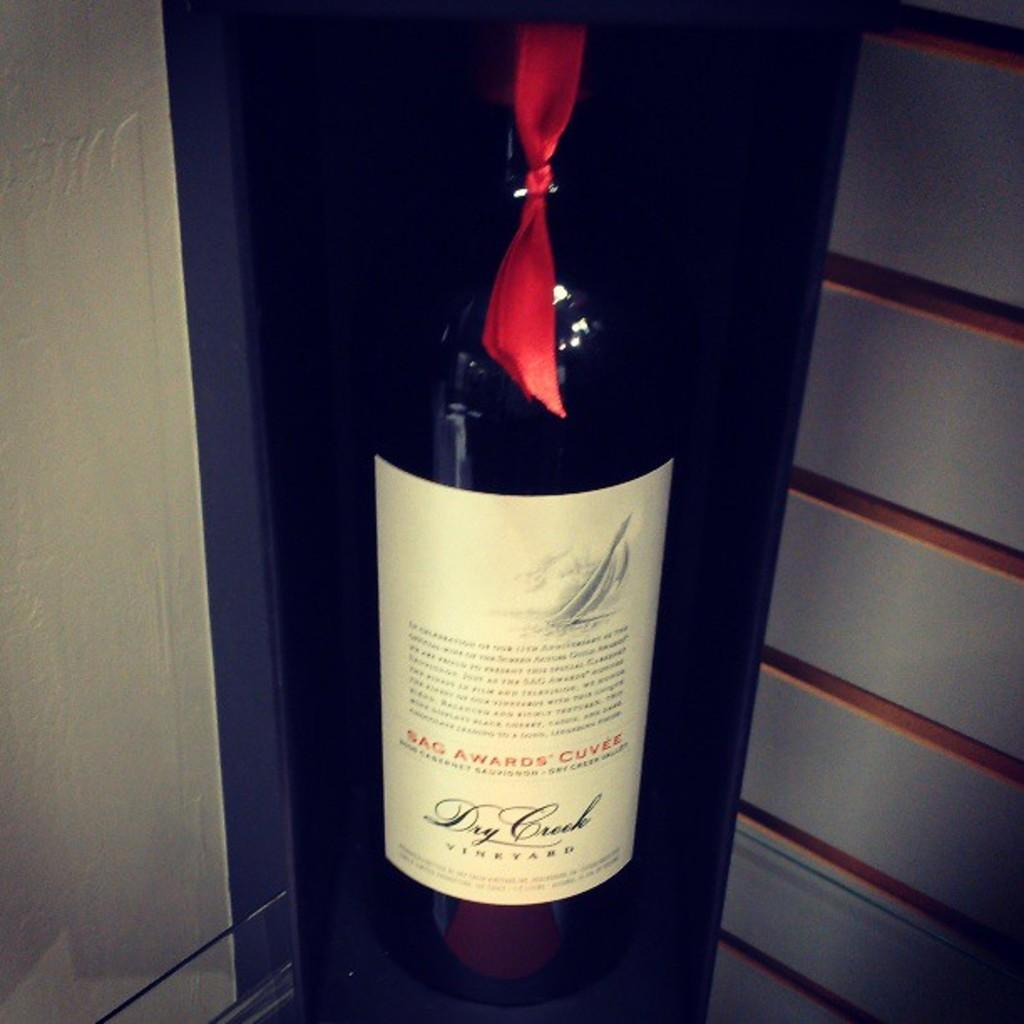Provide a one-sentence caption for the provided image. A bottle of Dry Crock Vineyard wine is on a display with a red ribbon tied around the neck. 